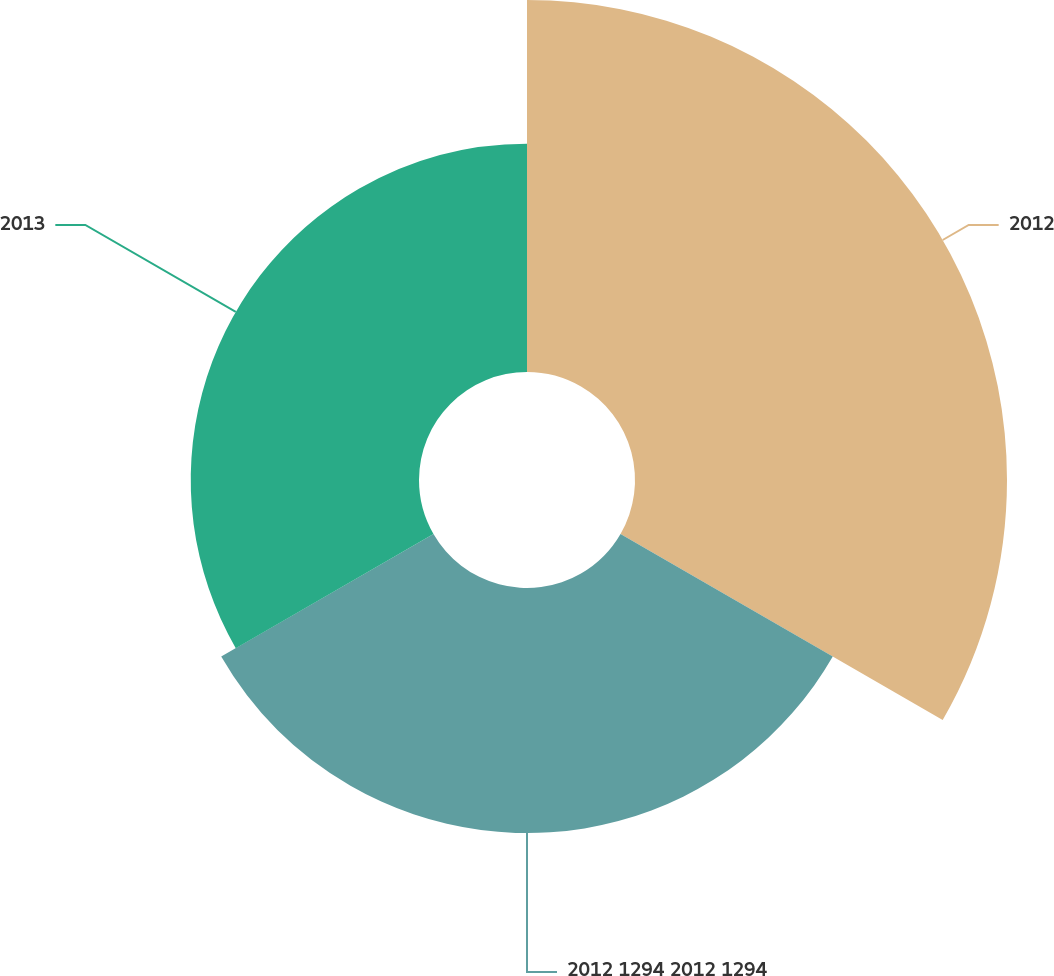Convert chart. <chart><loc_0><loc_0><loc_500><loc_500><pie_chart><fcel>2012<fcel>2012 1294 2012 1294<fcel>2013<nl><fcel>44.0%<fcel>28.99%<fcel>27.0%<nl></chart> 